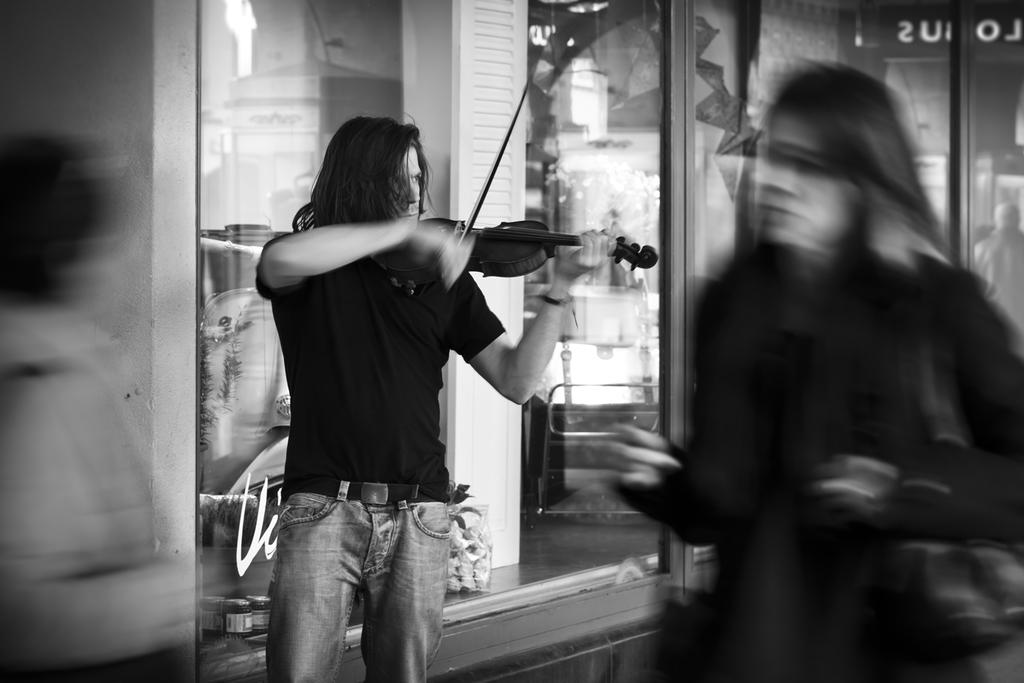What is the main subject of the image? The main subject of the image is a guy. What is the guy wearing in the image? The guy is wearing a black shirt in the image. What is the guy holding in the image? The guy is holding a guitar in the image. What is the guy doing with the guitar in the image? The guy is playing the guitar in the image. How many geese are flying in the image? There are no geese present in the image. What type of current is flowing through the guitar in the image? There is no current flowing through the guitar in the image; it is an electric guitar being played acoustically. 